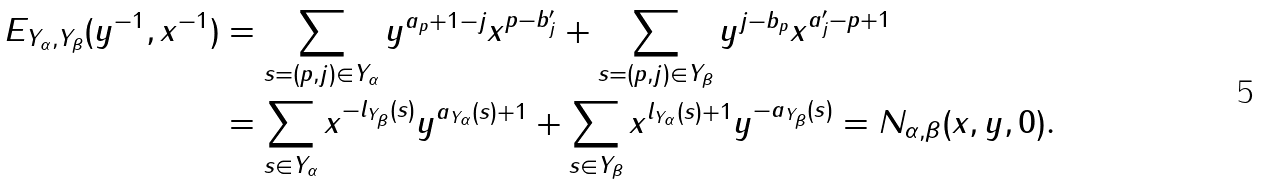Convert formula to latex. <formula><loc_0><loc_0><loc_500><loc_500>E _ { Y _ { \alpha } , Y _ { \beta } } ( y ^ { - 1 } , x ^ { - 1 } ) & = \sum _ { s = ( p , j ) \in Y _ { \alpha } } y ^ { a _ { p } + 1 - j } x ^ { p - b _ { j } ^ { \prime } } + \sum _ { s = ( p , j ) \in Y _ { \beta } } y ^ { j - b _ { p } } x ^ { a _ { j } ^ { \prime } - p + 1 } \\ & = \sum _ { s \in Y _ { \alpha } } x ^ { - l _ { Y _ { \beta } } ( s ) } y ^ { a _ { Y _ { \alpha } } ( s ) + 1 } + \sum _ { s \in Y _ { \beta } } x ^ { l _ { Y _ { \alpha } } ( s ) + 1 } y ^ { - a _ { Y _ { \beta } } ( s ) } = N _ { \alpha , \beta } ( x , y , 0 ) .</formula> 